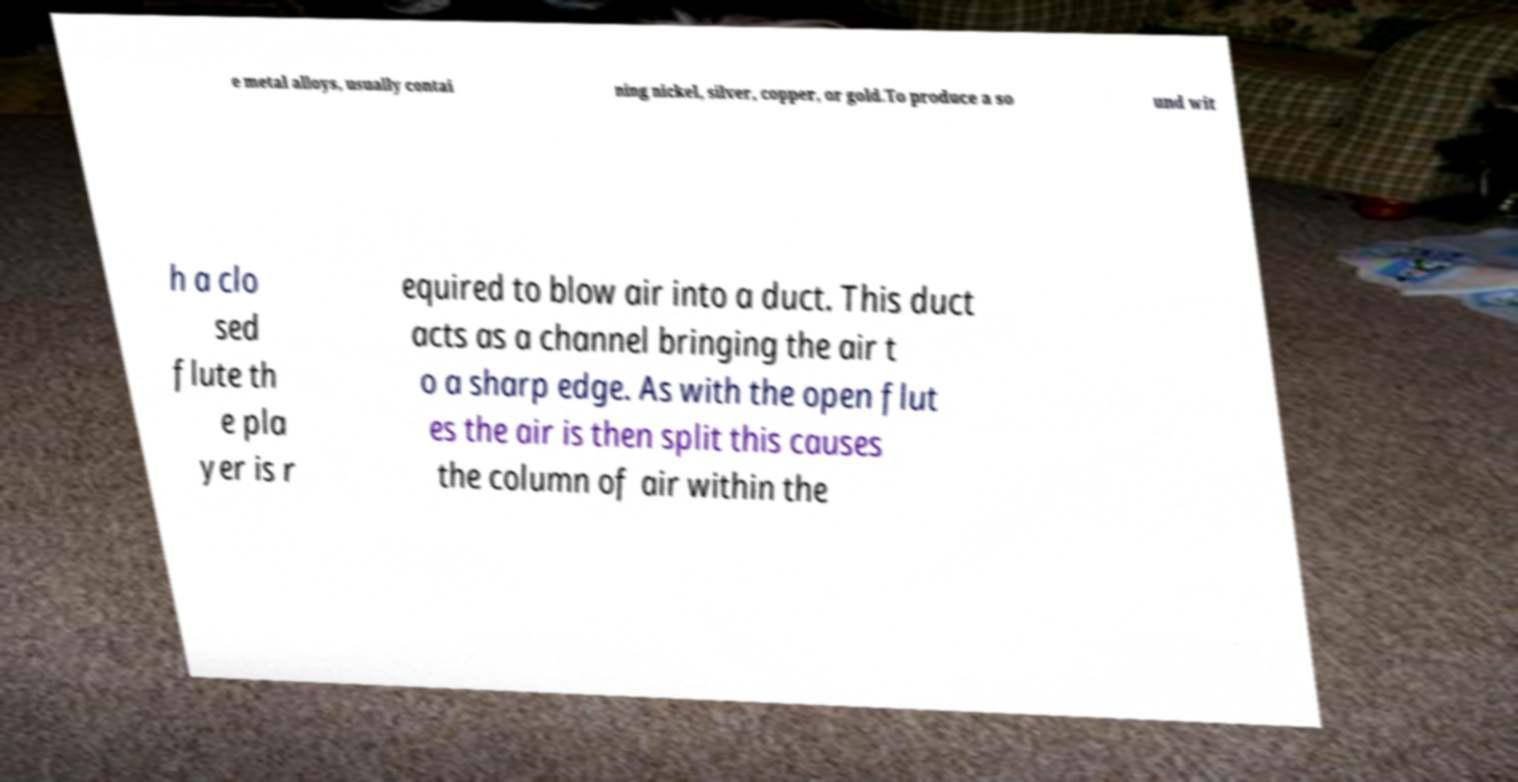Can you read and provide the text displayed in the image?This photo seems to have some interesting text. Can you extract and type it out for me? e metal alloys, usually contai ning nickel, silver, copper, or gold.To produce a so und wit h a clo sed flute th e pla yer is r equired to blow air into a duct. This duct acts as a channel bringing the air t o a sharp edge. As with the open flut es the air is then split this causes the column of air within the 